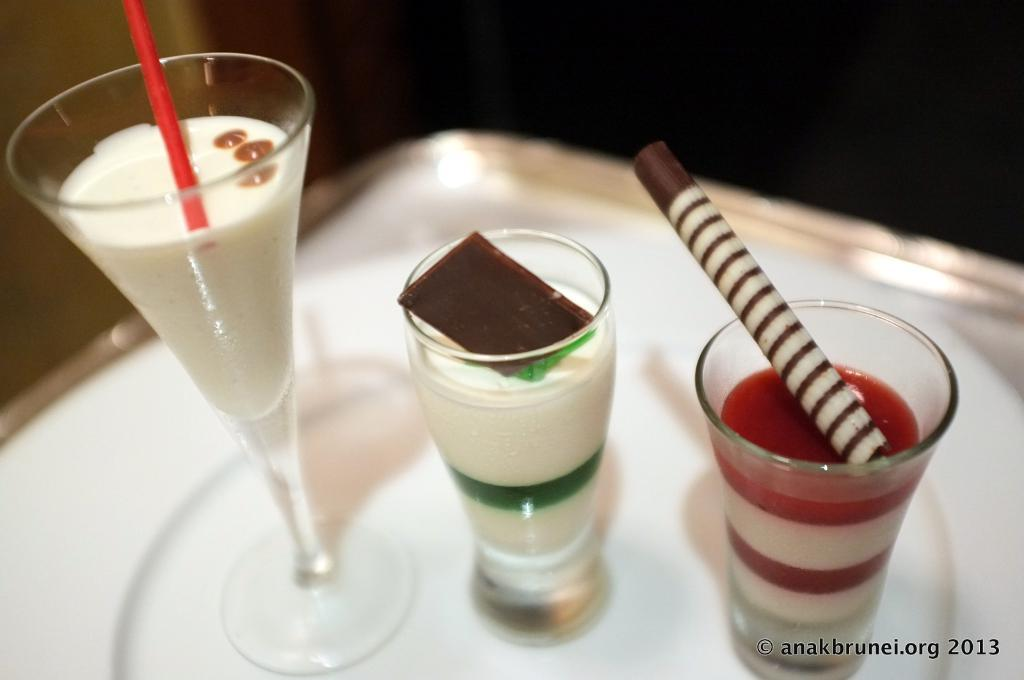What is present on the tray in the image? The tray contains glasses with different drinks. Can you describe the contents of the glasses? Unfortunately, the contents of the glasses cannot be determined from the image alone. Is there any additional information about the image in the right bottom corner? Yes, there is a watermark in the right bottom corner of the image. Where is the turkey located in the image? There is no turkey present in the image. What type of juice can be seen in the library in the image? There is no juice or library present in the image. 